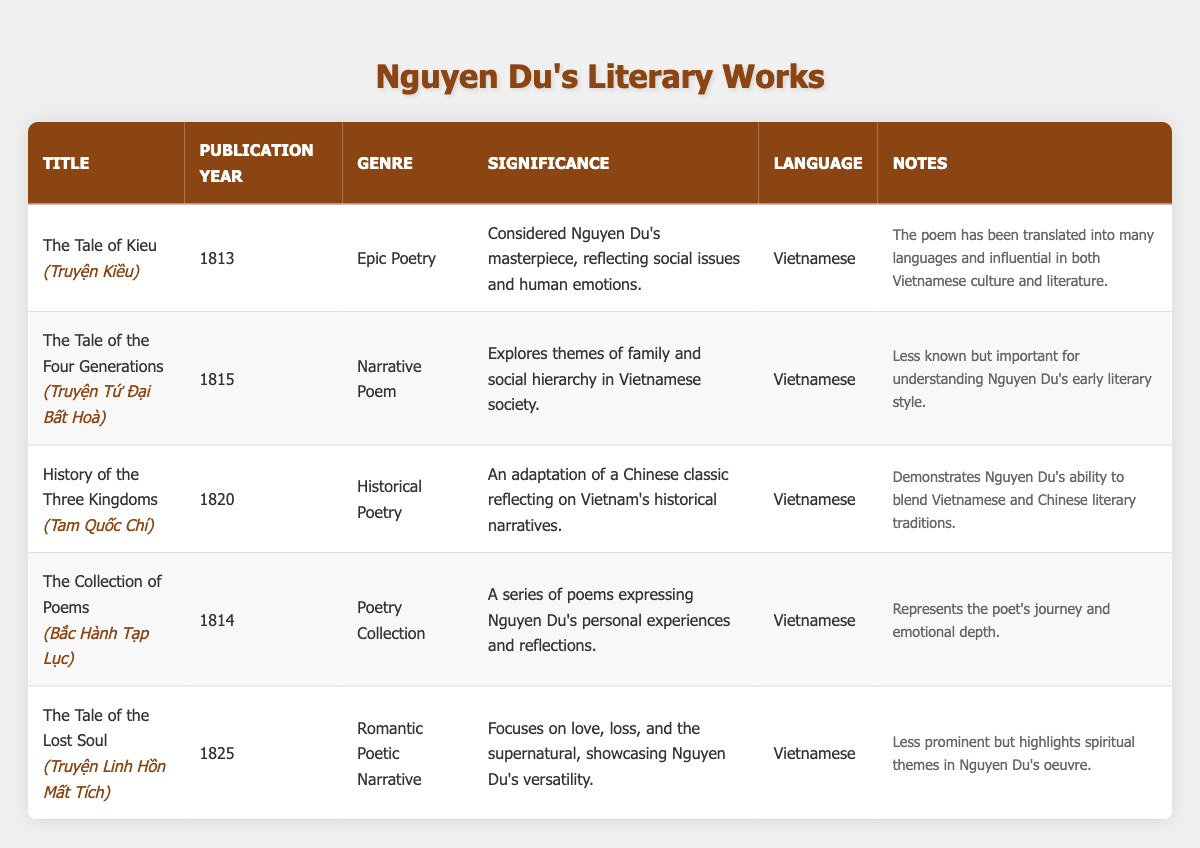What is the publication year of "The Tale of Kieu"? The table lists "The Tale of Kieu" with its details, including the publication year, which is mentioned as 1813.
Answer: 1813 Which literary work was published in 1820? By checking the publication years listed in the table, "History of the Three Kingdoms" is identified as the work published in 1820.
Answer: History of the Three Kingdoms How many works were published between 1813 and 1815? The works "The Tale of Kieu" (1813), "The Collection of Poems" (1814), and "The Tale of the Four Generations" (1815) were published in that timeframe. Counting them gives a total of 3 works.
Answer: 3 Is "The Tale of the Lost Soul" considered a masterpiece? The table does not categorize "The Tale of the Lost Soul" as a masterpiece; it describes "The Tale of Kieu" as Nguyen Du's masterpiece, while this work is noted to be less prominent.
Answer: No Which genre has the most works listed in the table? Upon examining the genres, "Epic Poetry" and "Poetry Collection" both have 2 works each, while "Narrative Poem," "Historical Poetry," and "Romantic Poetic Narrative" each have 1 work. Therefore, "Epic Poetry" and "Poetry Collection" have the most works listed.
Answer: Epic Poetry and Poetry Collection Identify the common language in which Nguyen Du's works were published. All entries in the table list "Vietnamese" as the language of publication for Nguyen Du's works.
Answer: Vietnamese What significant theme is highlighted in "The Tale of the Lost Soul"? The notes for "The Tale of the Lost Soul" indicate that it focuses on love, loss, and the supernatural, highlighting Nguyen Du's versatility in exploring different themes.
Answer: Love, loss, and the supernatural Which work of Nguyen Du explores family and social hierarchy? "The Tale of the Four Generations" is specified in the table as exploring themes of family and social hierarchy within Vietnamese society.
Answer: The Tale of the Four Generations What is the significance of "The Collection of Poems"? The table indicates that "The Collection of Poems" expresses Nguyen Du's personal experiences and reflections, signifying its importance in representing the poet's journey and emotional depth.
Answer: Expresses personal experiences and reflections 